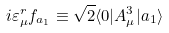<formula> <loc_0><loc_0><loc_500><loc_500>i \varepsilon ^ { r } _ { \mu } f _ { a _ { 1 } } \equiv \sqrt { 2 } \langle 0 | A _ { \mu } ^ { 3 } | a _ { 1 } \rangle</formula> 